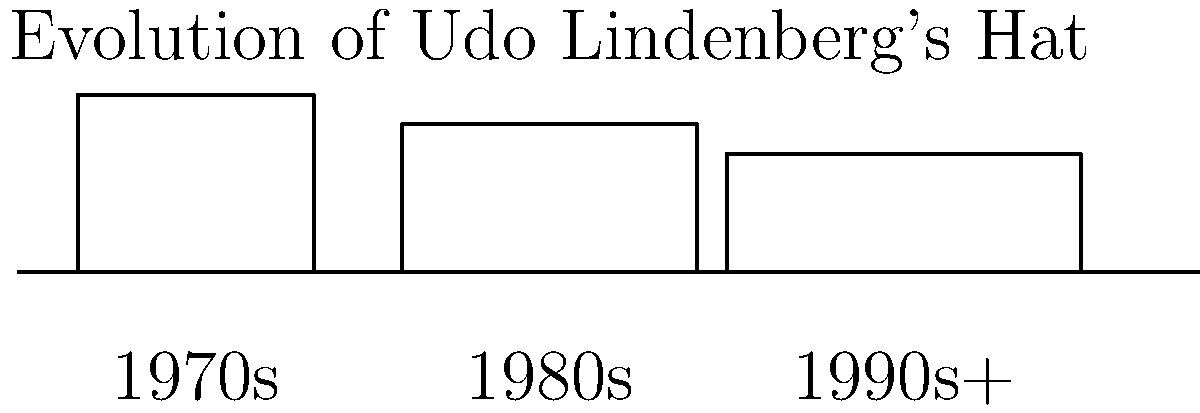Based on the evolution of Udo Lindenberg's iconic hat styles shown in the image, which decade marked the most significant change in the width of his hat's brim? To determine the decade with the most significant change in Udo Lindenberg's hat brim width, let's analyze the evolution step-by-step:

1. 1970s: The hat has a relatively narrow brim, estimated at about 10 units wide.

2. 1980s: The brim width increases to approximately 15 units. This represents a change of about 5 units from the 1970s.

3. 1990s and beyond: The brim width further increases to around 20 units. This is a change of about 5 units from the 1980s.

Comparing the changes:
- From 1970s to 1980s: 5 unit increase
- From 1980s to 1990s+: 5 unit increase

The change is consistent between each decade. However, the most significant change can be considered the initial widening from the 1970s to the 1980s, as it represents the first major shift in Lindenberg's iconic look.
Answer: 1980s 